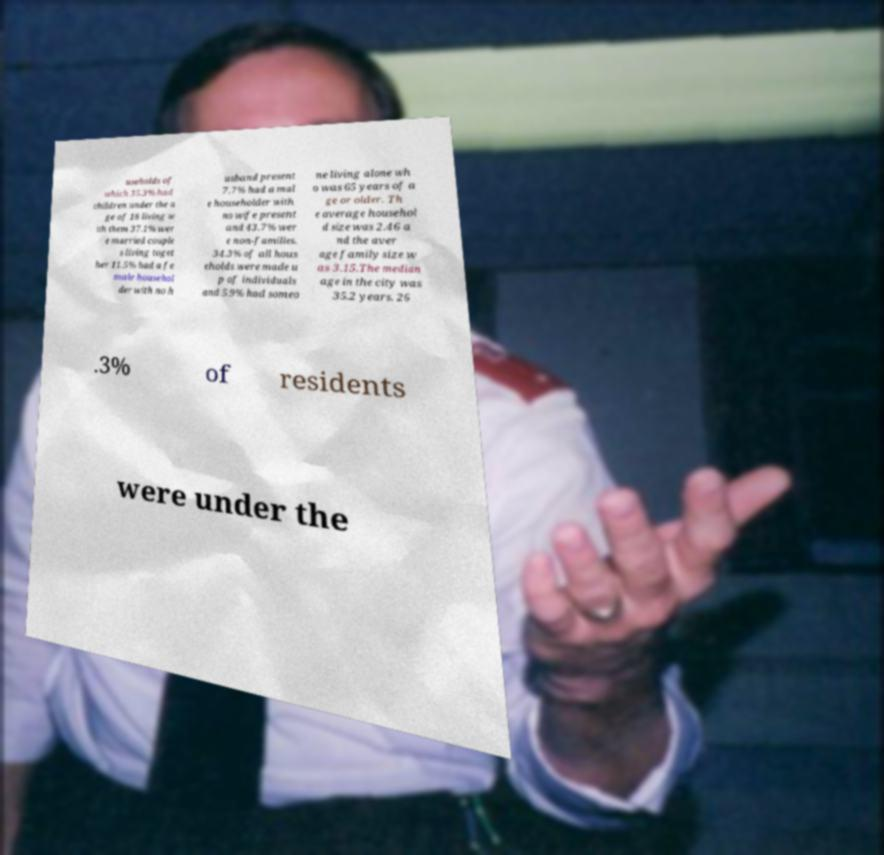Could you extract and type out the text from this image? useholds of which 35.3% had children under the a ge of 18 living w ith them 37.1% wer e married couple s living toget her 11.5% had a fe male househol der with no h usband present 7.7% had a mal e householder with no wife present and 43.7% wer e non-families. 34.3% of all hous eholds were made u p of individuals and 5.9% had someo ne living alone wh o was 65 years of a ge or older. Th e average househol d size was 2.46 a nd the aver age family size w as 3.15.The median age in the city was 35.2 years. 26 .3% of residents were under the 